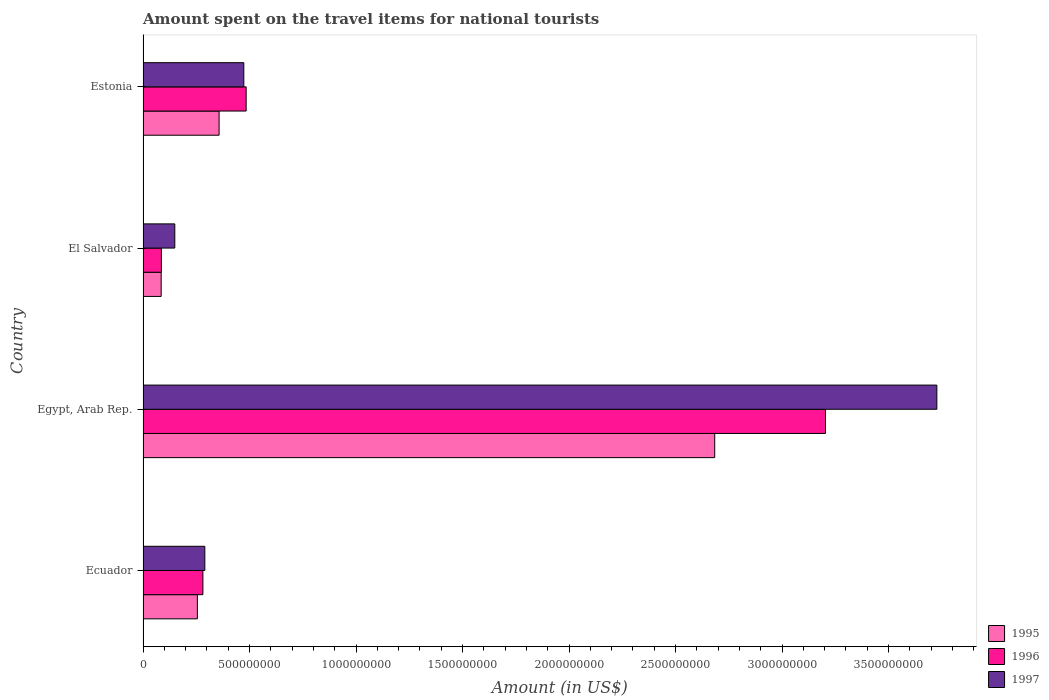How many different coloured bars are there?
Give a very brief answer. 3. How many groups of bars are there?
Provide a short and direct response. 4. Are the number of bars per tick equal to the number of legend labels?
Provide a short and direct response. Yes. How many bars are there on the 4th tick from the top?
Provide a short and direct response. 3. What is the label of the 4th group of bars from the top?
Keep it short and to the point. Ecuador. In how many cases, is the number of bars for a given country not equal to the number of legend labels?
Make the answer very short. 0. What is the amount spent on the travel items for national tourists in 1995 in Ecuador?
Your answer should be compact. 2.55e+08. Across all countries, what is the maximum amount spent on the travel items for national tourists in 1995?
Ensure brevity in your answer.  2.68e+09. Across all countries, what is the minimum amount spent on the travel items for national tourists in 1996?
Provide a short and direct response. 8.60e+07. In which country was the amount spent on the travel items for national tourists in 1995 maximum?
Keep it short and to the point. Egypt, Arab Rep. In which country was the amount spent on the travel items for national tourists in 1996 minimum?
Offer a very short reply. El Salvador. What is the total amount spent on the travel items for national tourists in 1997 in the graph?
Your answer should be compact. 4.64e+09. What is the difference between the amount spent on the travel items for national tourists in 1997 in Ecuador and that in El Salvador?
Your response must be concise. 1.41e+08. What is the difference between the amount spent on the travel items for national tourists in 1995 in Egypt, Arab Rep. and the amount spent on the travel items for national tourists in 1996 in Ecuador?
Make the answer very short. 2.40e+09. What is the average amount spent on the travel items for national tourists in 1995 per country?
Provide a succinct answer. 8.45e+08. What is the difference between the amount spent on the travel items for national tourists in 1997 and amount spent on the travel items for national tourists in 1996 in El Salvador?
Ensure brevity in your answer.  6.30e+07. What is the ratio of the amount spent on the travel items for national tourists in 1997 in Ecuador to that in Egypt, Arab Rep.?
Provide a succinct answer. 0.08. What is the difference between the highest and the second highest amount spent on the travel items for national tourists in 1995?
Give a very brief answer. 2.33e+09. What is the difference between the highest and the lowest amount spent on the travel items for national tourists in 1997?
Give a very brief answer. 3.58e+09. What does the 1st bar from the top in El Salvador represents?
Provide a short and direct response. 1997. What does the 3rd bar from the bottom in El Salvador represents?
Ensure brevity in your answer.  1997. Does the graph contain grids?
Provide a short and direct response. No. How many legend labels are there?
Your answer should be compact. 3. How are the legend labels stacked?
Your answer should be compact. Vertical. What is the title of the graph?
Give a very brief answer. Amount spent on the travel items for national tourists. What is the Amount (in US$) of 1995 in Ecuador?
Your response must be concise. 2.55e+08. What is the Amount (in US$) in 1996 in Ecuador?
Your answer should be compact. 2.81e+08. What is the Amount (in US$) of 1997 in Ecuador?
Your response must be concise. 2.90e+08. What is the Amount (in US$) of 1995 in Egypt, Arab Rep.?
Your response must be concise. 2.68e+09. What is the Amount (in US$) in 1996 in Egypt, Arab Rep.?
Ensure brevity in your answer.  3.20e+09. What is the Amount (in US$) of 1997 in Egypt, Arab Rep.?
Your response must be concise. 3.73e+09. What is the Amount (in US$) in 1995 in El Salvador?
Offer a terse response. 8.50e+07. What is the Amount (in US$) in 1996 in El Salvador?
Ensure brevity in your answer.  8.60e+07. What is the Amount (in US$) of 1997 in El Salvador?
Give a very brief answer. 1.49e+08. What is the Amount (in US$) of 1995 in Estonia?
Make the answer very short. 3.57e+08. What is the Amount (in US$) in 1996 in Estonia?
Provide a short and direct response. 4.84e+08. What is the Amount (in US$) in 1997 in Estonia?
Provide a short and direct response. 4.73e+08. Across all countries, what is the maximum Amount (in US$) in 1995?
Give a very brief answer. 2.68e+09. Across all countries, what is the maximum Amount (in US$) in 1996?
Offer a terse response. 3.20e+09. Across all countries, what is the maximum Amount (in US$) of 1997?
Keep it short and to the point. 3.73e+09. Across all countries, what is the minimum Amount (in US$) in 1995?
Offer a terse response. 8.50e+07. Across all countries, what is the minimum Amount (in US$) in 1996?
Give a very brief answer. 8.60e+07. Across all countries, what is the minimum Amount (in US$) of 1997?
Provide a short and direct response. 1.49e+08. What is the total Amount (in US$) of 1995 in the graph?
Keep it short and to the point. 3.38e+09. What is the total Amount (in US$) in 1996 in the graph?
Ensure brevity in your answer.  4.06e+09. What is the total Amount (in US$) of 1997 in the graph?
Ensure brevity in your answer.  4.64e+09. What is the difference between the Amount (in US$) in 1995 in Ecuador and that in Egypt, Arab Rep.?
Ensure brevity in your answer.  -2.43e+09. What is the difference between the Amount (in US$) in 1996 in Ecuador and that in Egypt, Arab Rep.?
Offer a very short reply. -2.92e+09. What is the difference between the Amount (in US$) of 1997 in Ecuador and that in Egypt, Arab Rep.?
Provide a short and direct response. -3.44e+09. What is the difference between the Amount (in US$) in 1995 in Ecuador and that in El Salvador?
Offer a terse response. 1.70e+08. What is the difference between the Amount (in US$) in 1996 in Ecuador and that in El Salvador?
Provide a succinct answer. 1.95e+08. What is the difference between the Amount (in US$) of 1997 in Ecuador and that in El Salvador?
Provide a short and direct response. 1.41e+08. What is the difference between the Amount (in US$) in 1995 in Ecuador and that in Estonia?
Give a very brief answer. -1.02e+08. What is the difference between the Amount (in US$) in 1996 in Ecuador and that in Estonia?
Offer a terse response. -2.03e+08. What is the difference between the Amount (in US$) in 1997 in Ecuador and that in Estonia?
Offer a very short reply. -1.83e+08. What is the difference between the Amount (in US$) in 1995 in Egypt, Arab Rep. and that in El Salvador?
Offer a very short reply. 2.60e+09. What is the difference between the Amount (in US$) in 1996 in Egypt, Arab Rep. and that in El Salvador?
Your answer should be compact. 3.12e+09. What is the difference between the Amount (in US$) in 1997 in Egypt, Arab Rep. and that in El Salvador?
Your response must be concise. 3.58e+09. What is the difference between the Amount (in US$) of 1995 in Egypt, Arab Rep. and that in Estonia?
Your answer should be very brief. 2.33e+09. What is the difference between the Amount (in US$) of 1996 in Egypt, Arab Rep. and that in Estonia?
Provide a succinct answer. 2.72e+09. What is the difference between the Amount (in US$) in 1997 in Egypt, Arab Rep. and that in Estonia?
Offer a terse response. 3.25e+09. What is the difference between the Amount (in US$) in 1995 in El Salvador and that in Estonia?
Your answer should be very brief. -2.72e+08. What is the difference between the Amount (in US$) in 1996 in El Salvador and that in Estonia?
Provide a short and direct response. -3.98e+08. What is the difference between the Amount (in US$) in 1997 in El Salvador and that in Estonia?
Keep it short and to the point. -3.24e+08. What is the difference between the Amount (in US$) in 1995 in Ecuador and the Amount (in US$) in 1996 in Egypt, Arab Rep.?
Make the answer very short. -2.95e+09. What is the difference between the Amount (in US$) in 1995 in Ecuador and the Amount (in US$) in 1997 in Egypt, Arab Rep.?
Your answer should be compact. -3.47e+09. What is the difference between the Amount (in US$) in 1996 in Ecuador and the Amount (in US$) in 1997 in Egypt, Arab Rep.?
Offer a very short reply. -3.45e+09. What is the difference between the Amount (in US$) of 1995 in Ecuador and the Amount (in US$) of 1996 in El Salvador?
Your answer should be compact. 1.69e+08. What is the difference between the Amount (in US$) of 1995 in Ecuador and the Amount (in US$) of 1997 in El Salvador?
Your response must be concise. 1.06e+08. What is the difference between the Amount (in US$) of 1996 in Ecuador and the Amount (in US$) of 1997 in El Salvador?
Your answer should be very brief. 1.32e+08. What is the difference between the Amount (in US$) of 1995 in Ecuador and the Amount (in US$) of 1996 in Estonia?
Offer a very short reply. -2.29e+08. What is the difference between the Amount (in US$) in 1995 in Ecuador and the Amount (in US$) in 1997 in Estonia?
Provide a succinct answer. -2.18e+08. What is the difference between the Amount (in US$) of 1996 in Ecuador and the Amount (in US$) of 1997 in Estonia?
Make the answer very short. -1.92e+08. What is the difference between the Amount (in US$) of 1995 in Egypt, Arab Rep. and the Amount (in US$) of 1996 in El Salvador?
Your response must be concise. 2.60e+09. What is the difference between the Amount (in US$) of 1995 in Egypt, Arab Rep. and the Amount (in US$) of 1997 in El Salvador?
Offer a terse response. 2.54e+09. What is the difference between the Amount (in US$) in 1996 in Egypt, Arab Rep. and the Amount (in US$) in 1997 in El Salvador?
Provide a succinct answer. 3.06e+09. What is the difference between the Amount (in US$) of 1995 in Egypt, Arab Rep. and the Amount (in US$) of 1996 in Estonia?
Give a very brief answer. 2.20e+09. What is the difference between the Amount (in US$) in 1995 in Egypt, Arab Rep. and the Amount (in US$) in 1997 in Estonia?
Ensure brevity in your answer.  2.21e+09. What is the difference between the Amount (in US$) in 1996 in Egypt, Arab Rep. and the Amount (in US$) in 1997 in Estonia?
Make the answer very short. 2.73e+09. What is the difference between the Amount (in US$) in 1995 in El Salvador and the Amount (in US$) in 1996 in Estonia?
Your answer should be very brief. -3.99e+08. What is the difference between the Amount (in US$) in 1995 in El Salvador and the Amount (in US$) in 1997 in Estonia?
Provide a succinct answer. -3.88e+08. What is the difference between the Amount (in US$) in 1996 in El Salvador and the Amount (in US$) in 1997 in Estonia?
Provide a succinct answer. -3.87e+08. What is the average Amount (in US$) in 1995 per country?
Your answer should be compact. 8.45e+08. What is the average Amount (in US$) in 1996 per country?
Provide a succinct answer. 1.01e+09. What is the average Amount (in US$) of 1997 per country?
Give a very brief answer. 1.16e+09. What is the difference between the Amount (in US$) in 1995 and Amount (in US$) in 1996 in Ecuador?
Ensure brevity in your answer.  -2.60e+07. What is the difference between the Amount (in US$) in 1995 and Amount (in US$) in 1997 in Ecuador?
Your response must be concise. -3.50e+07. What is the difference between the Amount (in US$) of 1996 and Amount (in US$) of 1997 in Ecuador?
Provide a succinct answer. -9.00e+06. What is the difference between the Amount (in US$) in 1995 and Amount (in US$) in 1996 in Egypt, Arab Rep.?
Provide a succinct answer. -5.20e+08. What is the difference between the Amount (in US$) of 1995 and Amount (in US$) of 1997 in Egypt, Arab Rep.?
Offer a very short reply. -1.04e+09. What is the difference between the Amount (in US$) of 1996 and Amount (in US$) of 1997 in Egypt, Arab Rep.?
Ensure brevity in your answer.  -5.23e+08. What is the difference between the Amount (in US$) in 1995 and Amount (in US$) in 1996 in El Salvador?
Make the answer very short. -1.00e+06. What is the difference between the Amount (in US$) in 1995 and Amount (in US$) in 1997 in El Salvador?
Give a very brief answer. -6.40e+07. What is the difference between the Amount (in US$) in 1996 and Amount (in US$) in 1997 in El Salvador?
Provide a short and direct response. -6.30e+07. What is the difference between the Amount (in US$) of 1995 and Amount (in US$) of 1996 in Estonia?
Provide a short and direct response. -1.27e+08. What is the difference between the Amount (in US$) of 1995 and Amount (in US$) of 1997 in Estonia?
Provide a succinct answer. -1.16e+08. What is the difference between the Amount (in US$) of 1996 and Amount (in US$) of 1997 in Estonia?
Offer a very short reply. 1.10e+07. What is the ratio of the Amount (in US$) of 1995 in Ecuador to that in Egypt, Arab Rep.?
Give a very brief answer. 0.1. What is the ratio of the Amount (in US$) in 1996 in Ecuador to that in Egypt, Arab Rep.?
Provide a succinct answer. 0.09. What is the ratio of the Amount (in US$) of 1997 in Ecuador to that in Egypt, Arab Rep.?
Your answer should be very brief. 0.08. What is the ratio of the Amount (in US$) of 1996 in Ecuador to that in El Salvador?
Your answer should be compact. 3.27. What is the ratio of the Amount (in US$) in 1997 in Ecuador to that in El Salvador?
Your answer should be very brief. 1.95. What is the ratio of the Amount (in US$) of 1995 in Ecuador to that in Estonia?
Make the answer very short. 0.71. What is the ratio of the Amount (in US$) of 1996 in Ecuador to that in Estonia?
Offer a terse response. 0.58. What is the ratio of the Amount (in US$) in 1997 in Ecuador to that in Estonia?
Your answer should be compact. 0.61. What is the ratio of the Amount (in US$) of 1995 in Egypt, Arab Rep. to that in El Salvador?
Ensure brevity in your answer.  31.58. What is the ratio of the Amount (in US$) of 1996 in Egypt, Arab Rep. to that in El Salvador?
Ensure brevity in your answer.  37.26. What is the ratio of the Amount (in US$) in 1997 in Egypt, Arab Rep. to that in El Salvador?
Ensure brevity in your answer.  25.01. What is the ratio of the Amount (in US$) of 1995 in Egypt, Arab Rep. to that in Estonia?
Provide a short and direct response. 7.52. What is the ratio of the Amount (in US$) of 1996 in Egypt, Arab Rep. to that in Estonia?
Provide a short and direct response. 6.62. What is the ratio of the Amount (in US$) of 1997 in Egypt, Arab Rep. to that in Estonia?
Provide a short and direct response. 7.88. What is the ratio of the Amount (in US$) of 1995 in El Salvador to that in Estonia?
Give a very brief answer. 0.24. What is the ratio of the Amount (in US$) in 1996 in El Salvador to that in Estonia?
Ensure brevity in your answer.  0.18. What is the ratio of the Amount (in US$) in 1997 in El Salvador to that in Estonia?
Make the answer very short. 0.32. What is the difference between the highest and the second highest Amount (in US$) of 1995?
Offer a very short reply. 2.33e+09. What is the difference between the highest and the second highest Amount (in US$) of 1996?
Your answer should be very brief. 2.72e+09. What is the difference between the highest and the second highest Amount (in US$) of 1997?
Offer a terse response. 3.25e+09. What is the difference between the highest and the lowest Amount (in US$) in 1995?
Offer a terse response. 2.60e+09. What is the difference between the highest and the lowest Amount (in US$) in 1996?
Keep it short and to the point. 3.12e+09. What is the difference between the highest and the lowest Amount (in US$) in 1997?
Your answer should be compact. 3.58e+09. 